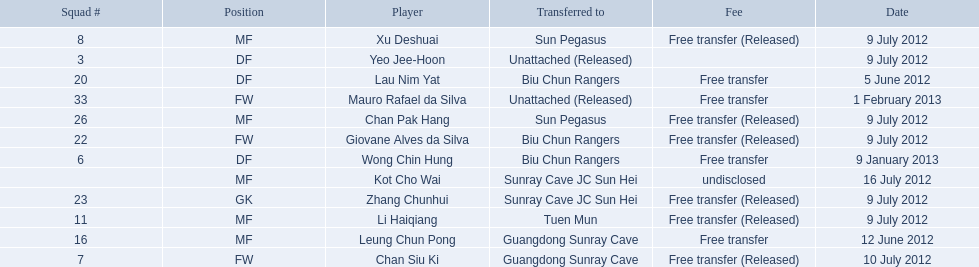Which players played during the 2012-13 south china aa season? Lau Nim Yat, Leung Chun Pong, Yeo Jee-Hoon, Xu Deshuai, Li Haiqiang, Giovane Alves da Silva, Zhang Chunhui, Chan Pak Hang, Chan Siu Ki, Kot Cho Wai, Wong Chin Hung, Mauro Rafael da Silva. Of these, which were free transfers that were not released? Lau Nim Yat, Leung Chun Pong, Wong Chin Hung, Mauro Rafael da Silva. Of these, which were in squad # 6? Wong Chin Hung. What was the date of his transfer? 9 January 2013. 